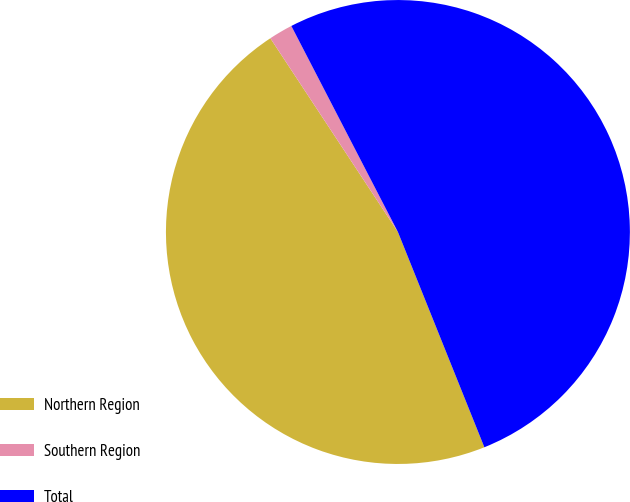Convert chart. <chart><loc_0><loc_0><loc_500><loc_500><pie_chart><fcel>Northern Region<fcel>Southern Region<fcel>Total<nl><fcel>46.81%<fcel>1.67%<fcel>51.52%<nl></chart> 